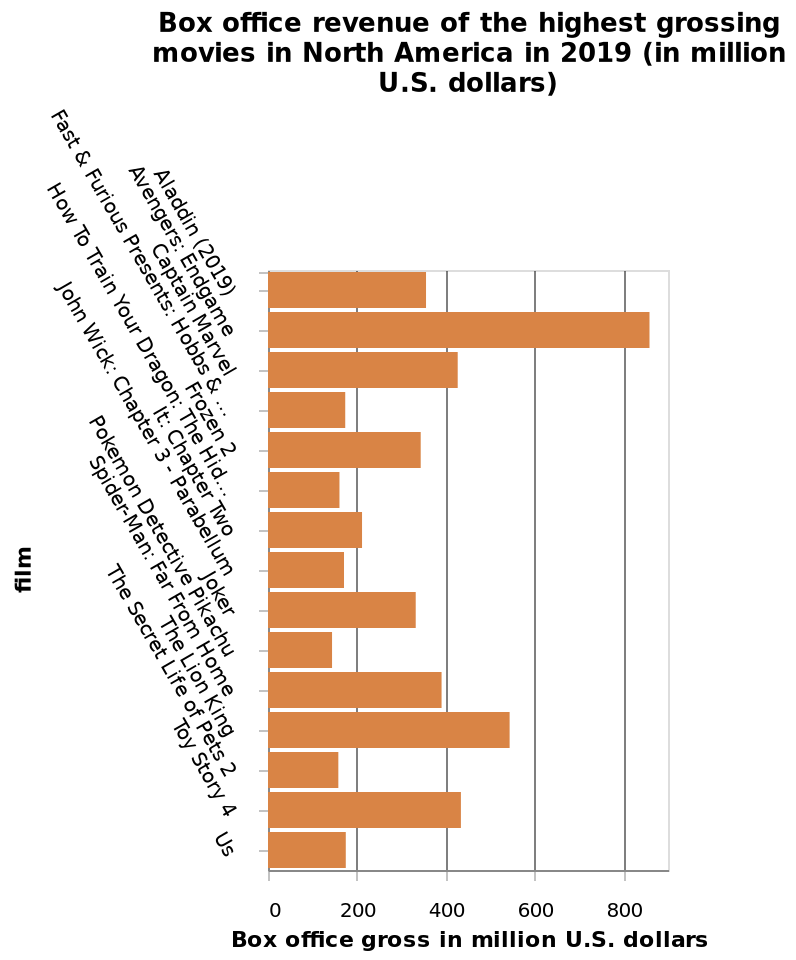<image>
How many movies made more than 400 million dollars?  4 movies How much money did Avengers end game make? unknown What is the range of the x-axis scale? The range of the x-axis scale is from 0 to 800, marked as Box office gross in million U.S. dollars. 